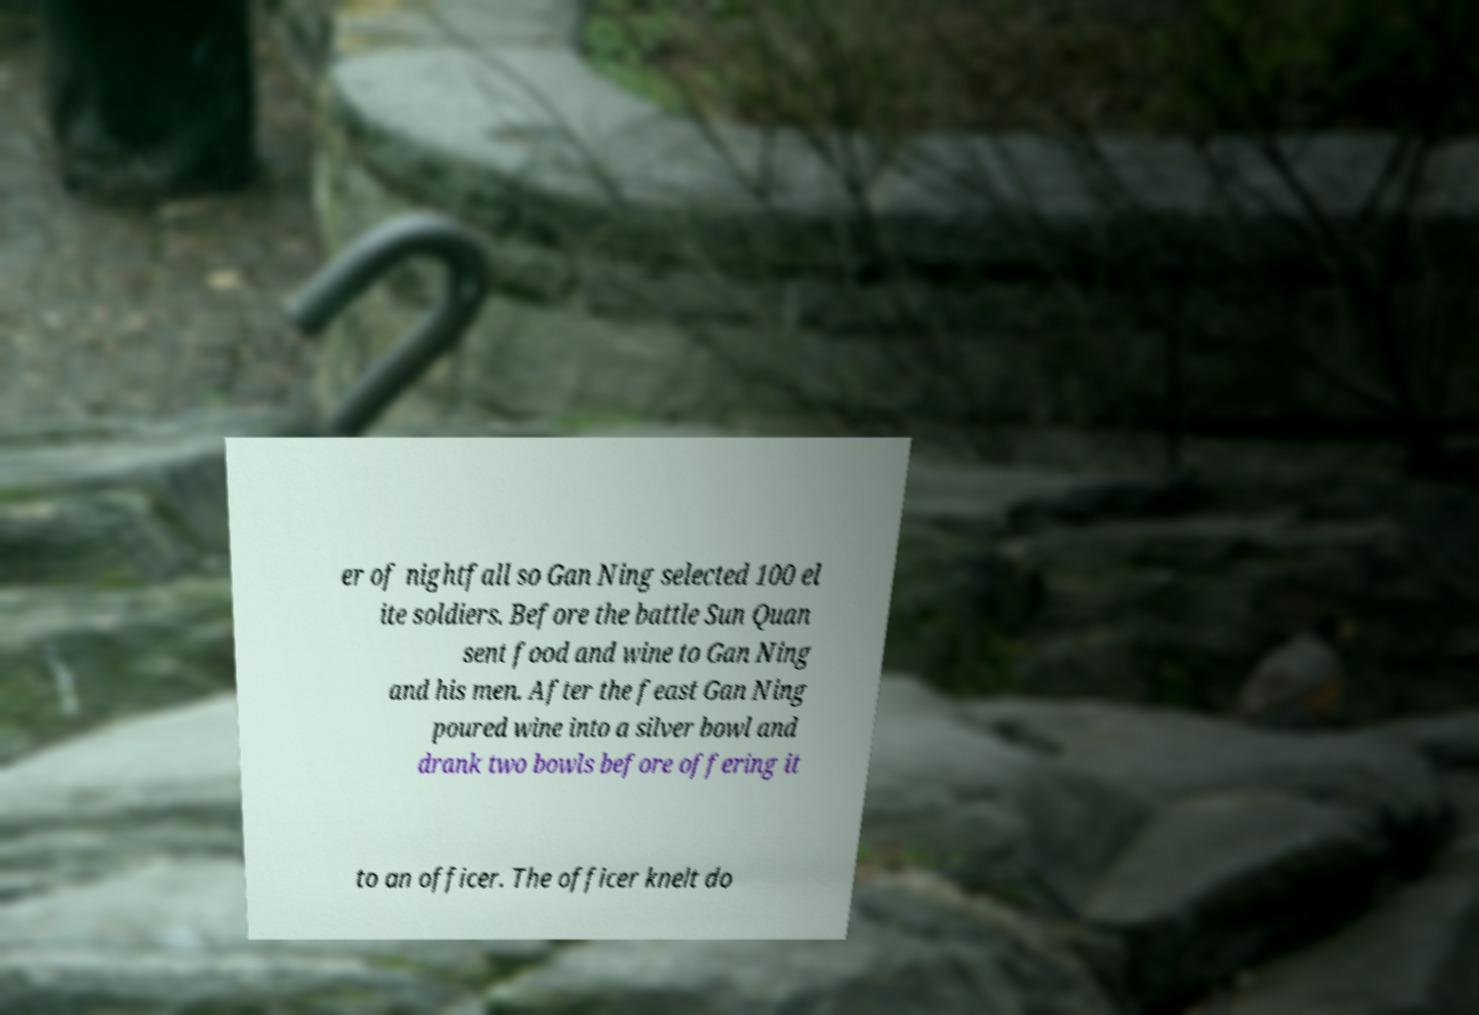There's text embedded in this image that I need extracted. Can you transcribe it verbatim? er of nightfall so Gan Ning selected 100 el ite soldiers. Before the battle Sun Quan sent food and wine to Gan Ning and his men. After the feast Gan Ning poured wine into a silver bowl and drank two bowls before offering it to an officer. The officer knelt do 